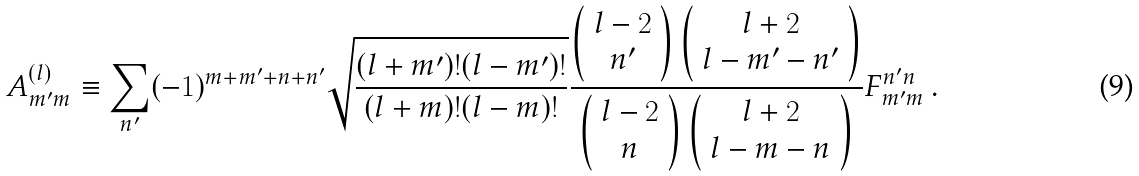<formula> <loc_0><loc_0><loc_500><loc_500>A ^ { ( l ) } _ { m ^ { \prime } m } \equiv \sum _ { n ^ { \prime } } ( - 1 ) ^ { m + m ^ { \prime } + n + n ^ { \prime } } \sqrt { \frac { ( l + m ^ { \prime } ) ! ( l - m ^ { \prime } ) ! } { ( l + m ) ! ( l - m ) ! } } \frac { \left ( \begin{array} { c } l - 2 \\ n ^ { \prime } \\ \end{array} \right ) \left ( \begin{array} { c } l + 2 \\ l - m ^ { \prime } - n ^ { \prime } \\ \end{array} \right ) } { \left ( \begin{array} { c } l - 2 \\ n \\ \end{array} \right ) \left ( \begin{array} { c } l + 2 \\ l - m - n \\ \end{array} \right ) } F _ { m ^ { \prime } m } ^ { n ^ { \prime } n } \, .</formula> 